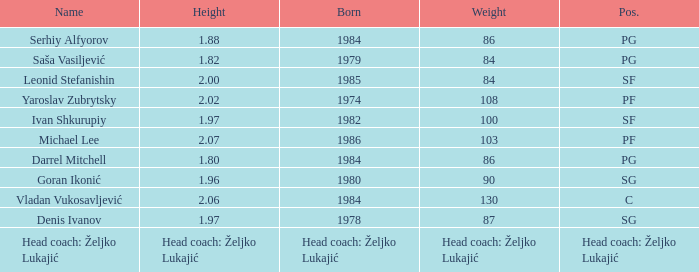What was the weight of Serhiy Alfyorov? 86.0. 